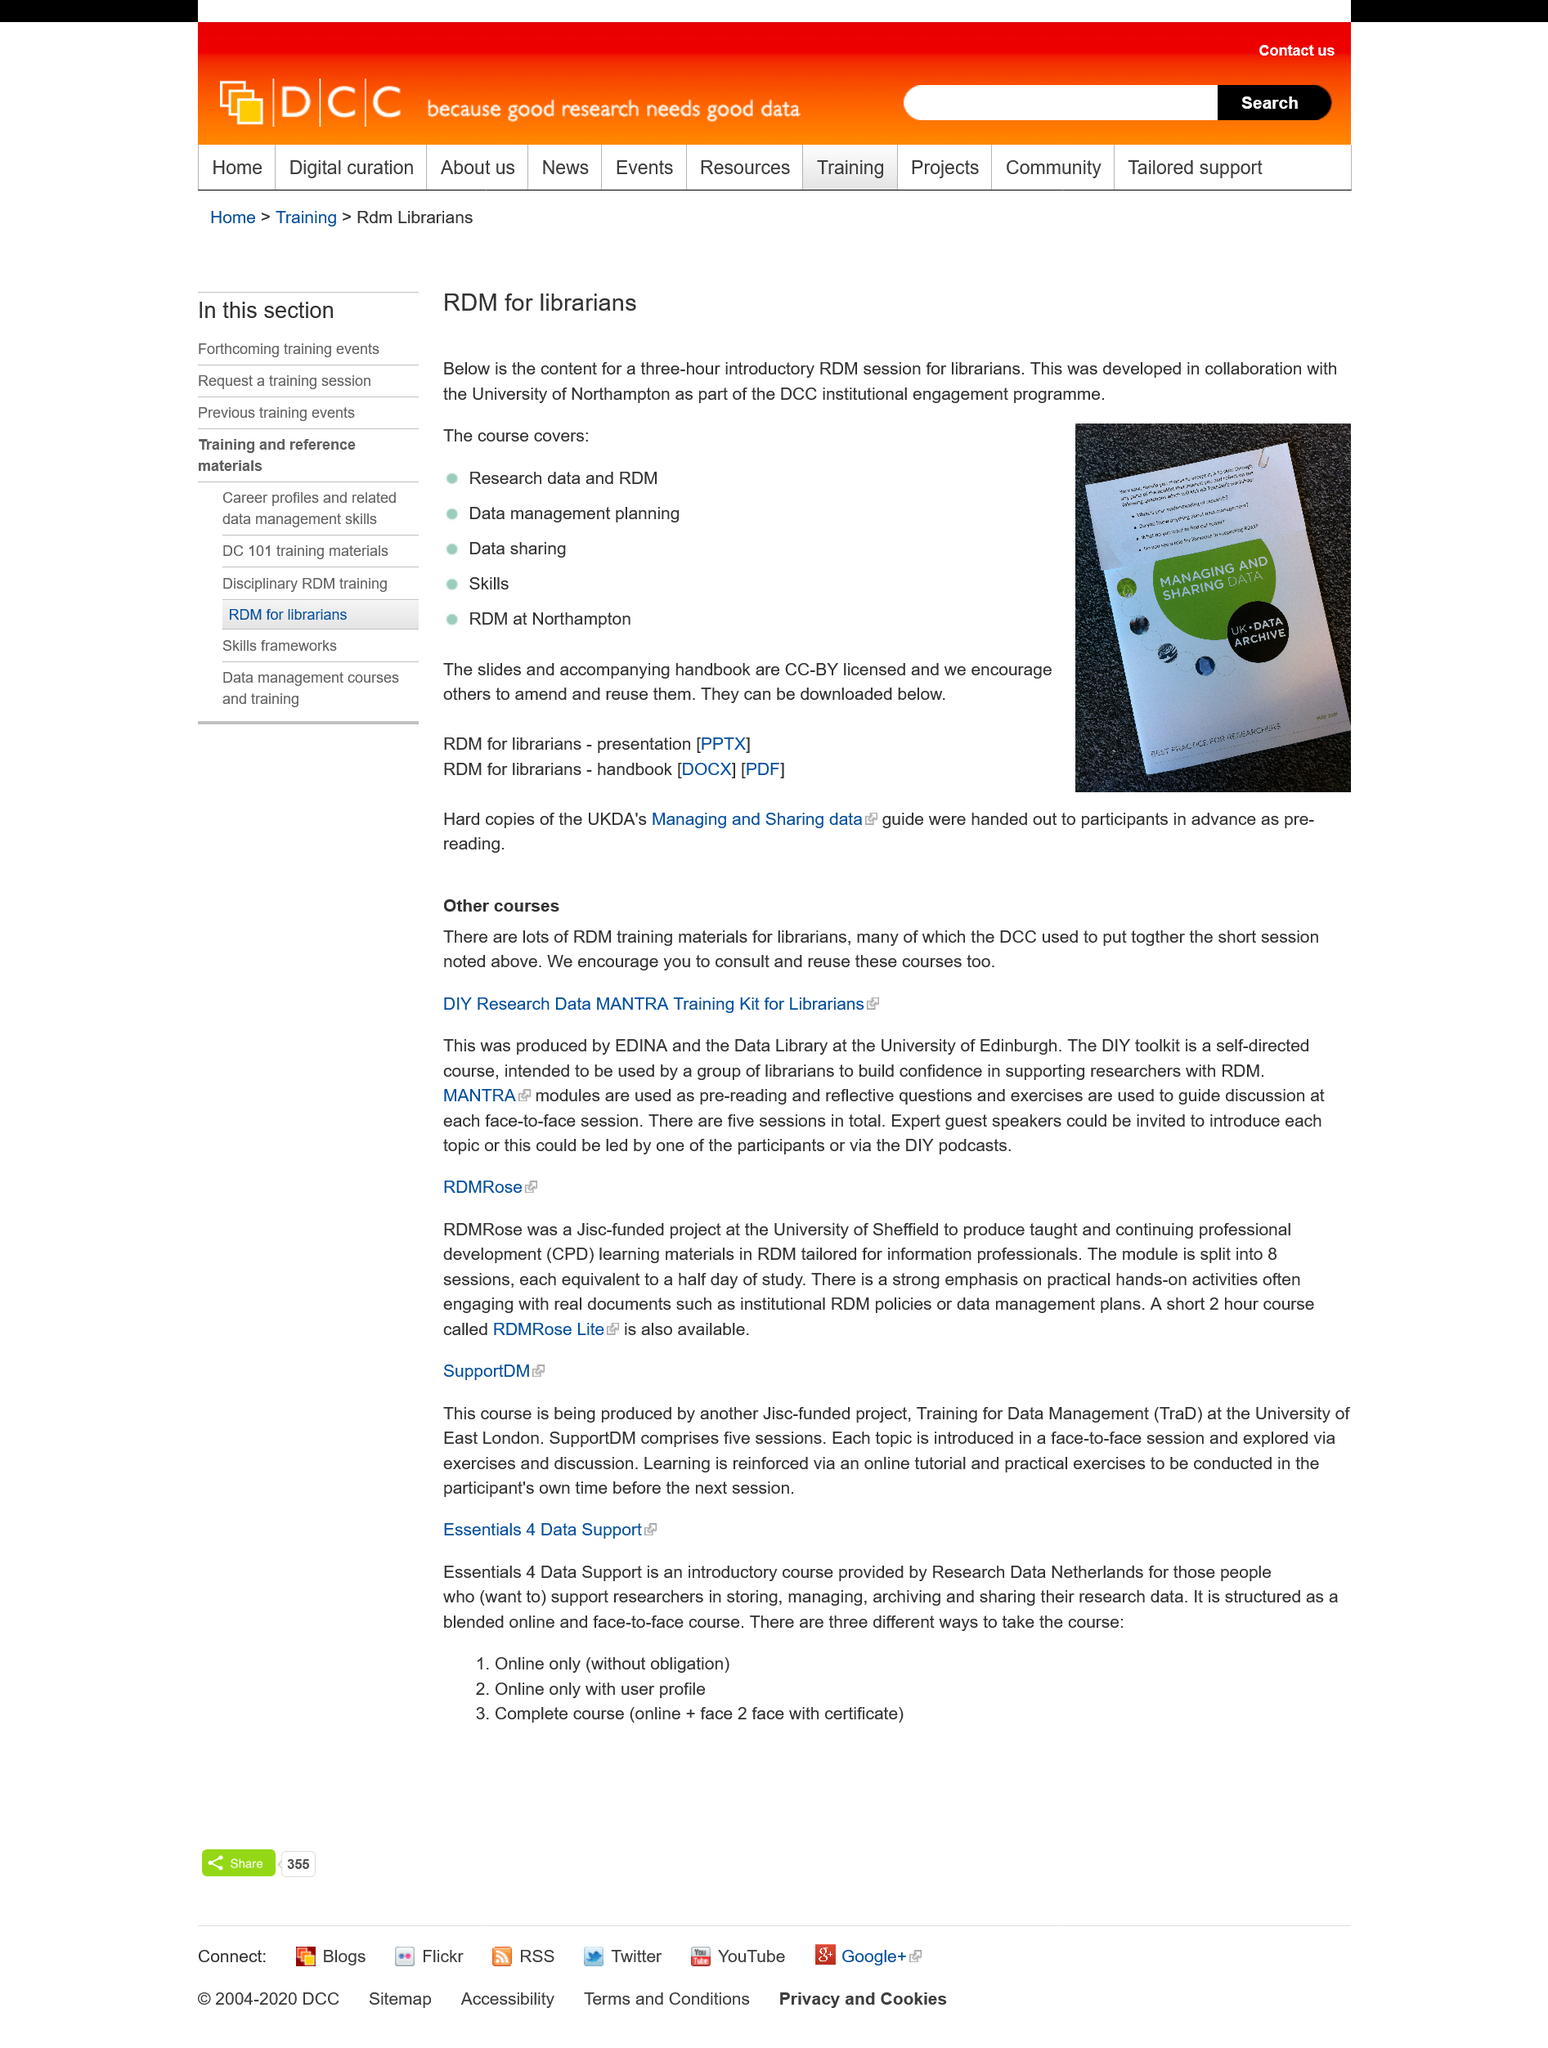Draw attention to some important aspects in this diagram. This course includes a comprehensive coverage of Data Management Planning, which is a critical component of data analysis and management processes. The University of Northampton was involved in the development of this course. The introductory course lasts for 3 hours. 